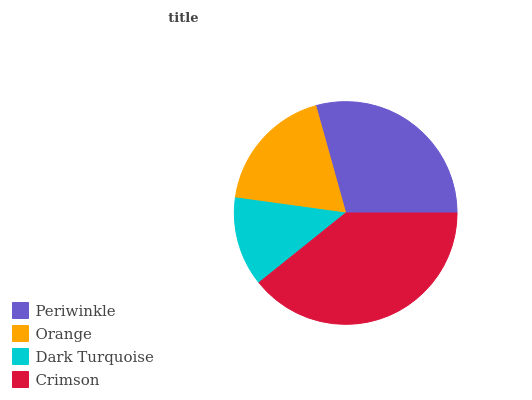Is Dark Turquoise the minimum?
Answer yes or no. Yes. Is Crimson the maximum?
Answer yes or no. Yes. Is Orange the minimum?
Answer yes or no. No. Is Orange the maximum?
Answer yes or no. No. Is Periwinkle greater than Orange?
Answer yes or no. Yes. Is Orange less than Periwinkle?
Answer yes or no. Yes. Is Orange greater than Periwinkle?
Answer yes or no. No. Is Periwinkle less than Orange?
Answer yes or no. No. Is Periwinkle the high median?
Answer yes or no. Yes. Is Orange the low median?
Answer yes or no. Yes. Is Dark Turquoise the high median?
Answer yes or no. No. Is Dark Turquoise the low median?
Answer yes or no. No. 